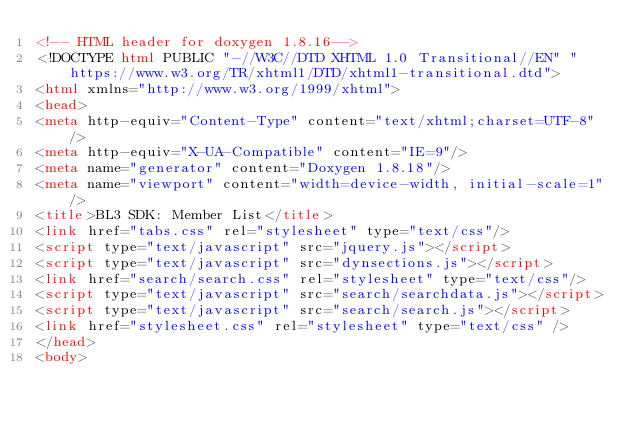<code> <loc_0><loc_0><loc_500><loc_500><_HTML_><!-- HTML header for doxygen 1.8.16-->
<!DOCTYPE html PUBLIC "-//W3C//DTD XHTML 1.0 Transitional//EN" "https://www.w3.org/TR/xhtml1/DTD/xhtml1-transitional.dtd">
<html xmlns="http://www.w3.org/1999/xhtml">
<head>
<meta http-equiv="Content-Type" content="text/xhtml;charset=UTF-8"/>
<meta http-equiv="X-UA-Compatible" content="IE=9"/>
<meta name="generator" content="Doxygen 1.8.18"/>
<meta name="viewport" content="width=device-width, initial-scale=1"/>
<title>BL3 SDK: Member List</title>
<link href="tabs.css" rel="stylesheet" type="text/css"/>
<script type="text/javascript" src="jquery.js"></script>
<script type="text/javascript" src="dynsections.js"></script>
<link href="search/search.css" rel="stylesheet" type="text/css"/>
<script type="text/javascript" src="search/searchdata.js"></script>
<script type="text/javascript" src="search/search.js"></script>
<link href="stylesheet.css" rel="stylesheet" type="text/css" />
</head>
<body></code> 